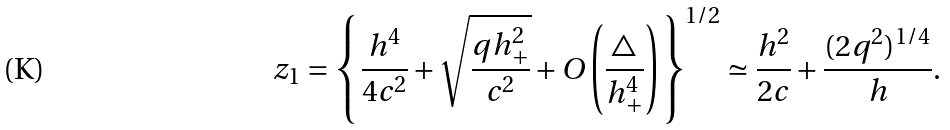Convert formula to latex. <formula><loc_0><loc_0><loc_500><loc_500>z _ { 1 } = \left \{ \frac { h ^ { 4 } } { 4 c ^ { 2 } } + \sqrt { \frac { q h ^ { 2 } _ { + } } { c ^ { 2 } } } + O \left ( \frac { \triangle } { h _ { + } ^ { 4 } } \right ) \right \} ^ { 1 / 2 } \simeq \frac { h ^ { 2 } } { 2 c } + \frac { ( 2 q ^ { 2 } ) ^ { 1 / 4 } } { h } .</formula> 